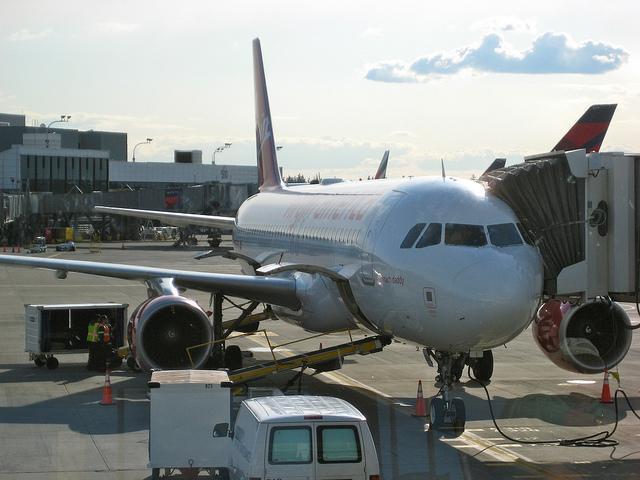Who created the first successful vehicle of this type?
Indicate the correct choice and explain in the format: 'Answer: answer
Rationale: rationale.'
Options: Elon musk, nikola tesla, orville wright, karl benz. Answer: orville wright.
Rationale: Orville and wilbur wright invented the first successful airplane in 1903. 